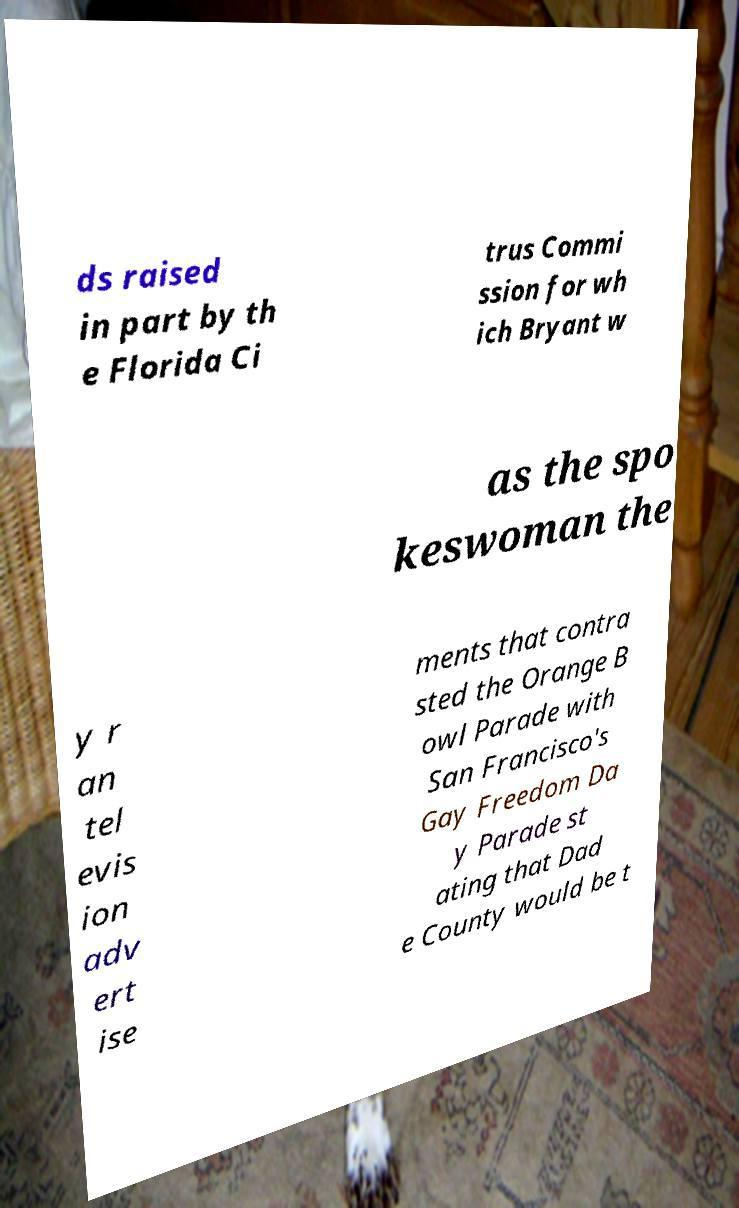Could you extract and type out the text from this image? ds raised in part by th e Florida Ci trus Commi ssion for wh ich Bryant w as the spo keswoman the y r an tel evis ion adv ert ise ments that contra sted the Orange B owl Parade with San Francisco's Gay Freedom Da y Parade st ating that Dad e County would be t 